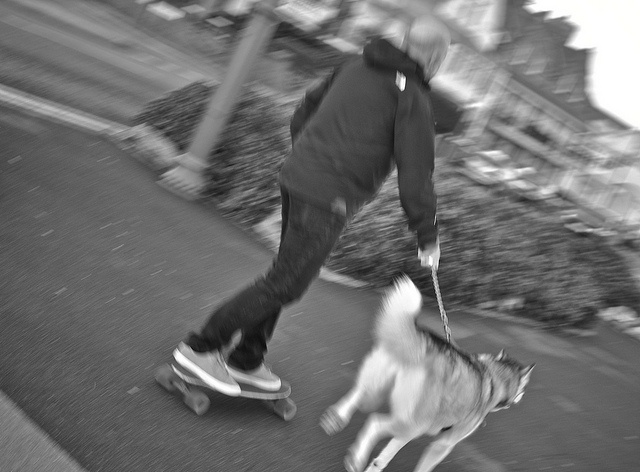Describe the objects in this image and their specific colors. I can see people in gray, black, darkgray, and lightgray tones, dog in gray, darkgray, lightgray, and black tones, skateboard in gray, black, and lightgray tones, and car in lightgray, darkgray, and gray tones in this image. 